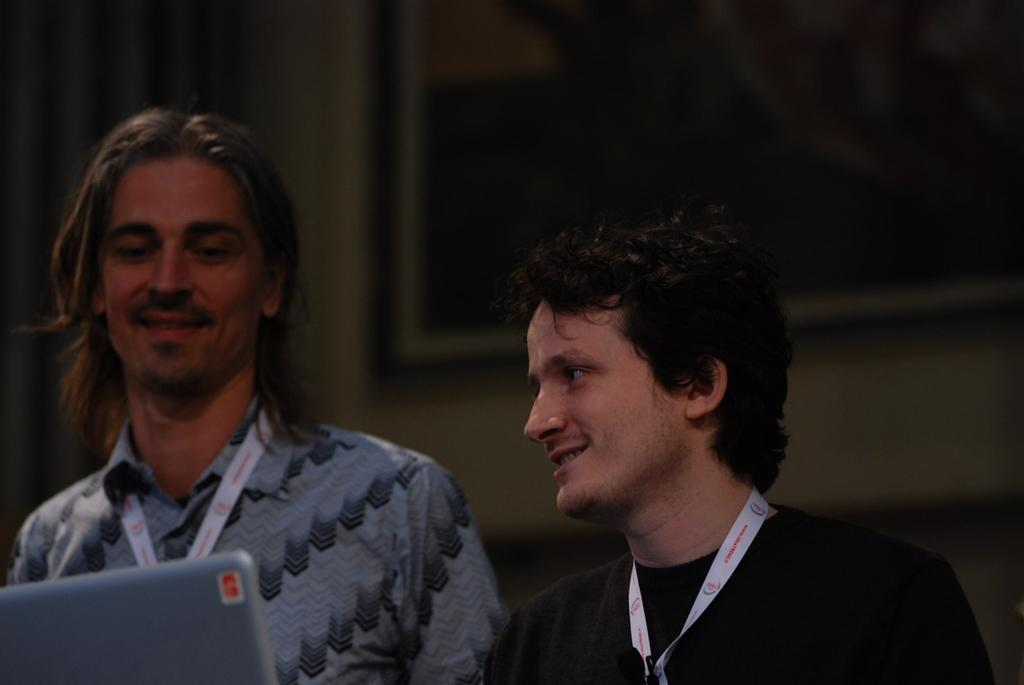How many people are present in the image? There are two persons in the image. What electronic device can be seen in the image? There is a laptop in the left corner of the image. Is there any decorative item visible in the background of the image? Yes, there is a photo frame attached to the wall in the background of the image. What type of toad can be seen sitting on the laptop in the image? There is no toad present in the image, and the laptop is not being used by any animal. How many beads are visible on the persons in the image? There is no mention of beads in the image, and neither person is wearing any. 